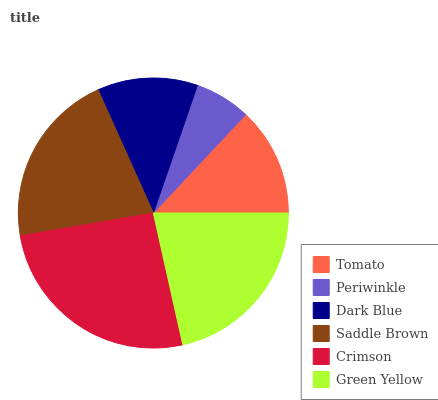Is Periwinkle the minimum?
Answer yes or no. Yes. Is Crimson the maximum?
Answer yes or no. Yes. Is Dark Blue the minimum?
Answer yes or no. No. Is Dark Blue the maximum?
Answer yes or no. No. Is Dark Blue greater than Periwinkle?
Answer yes or no. Yes. Is Periwinkle less than Dark Blue?
Answer yes or no. Yes. Is Periwinkle greater than Dark Blue?
Answer yes or no. No. Is Dark Blue less than Periwinkle?
Answer yes or no. No. Is Saddle Brown the high median?
Answer yes or no. Yes. Is Tomato the low median?
Answer yes or no. Yes. Is Periwinkle the high median?
Answer yes or no. No. Is Dark Blue the low median?
Answer yes or no. No. 